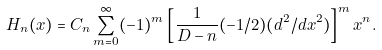<formula> <loc_0><loc_0><loc_500><loc_500>H _ { n } ( x ) = C _ { n } \sum _ { m = 0 } ^ { \infty } ( - 1 ) ^ { m } \left [ \frac { 1 } { D - n } ( - 1 / 2 ) ( d ^ { 2 } / d x ^ { 2 } ) \right ] ^ { m } x ^ { n } .</formula> 